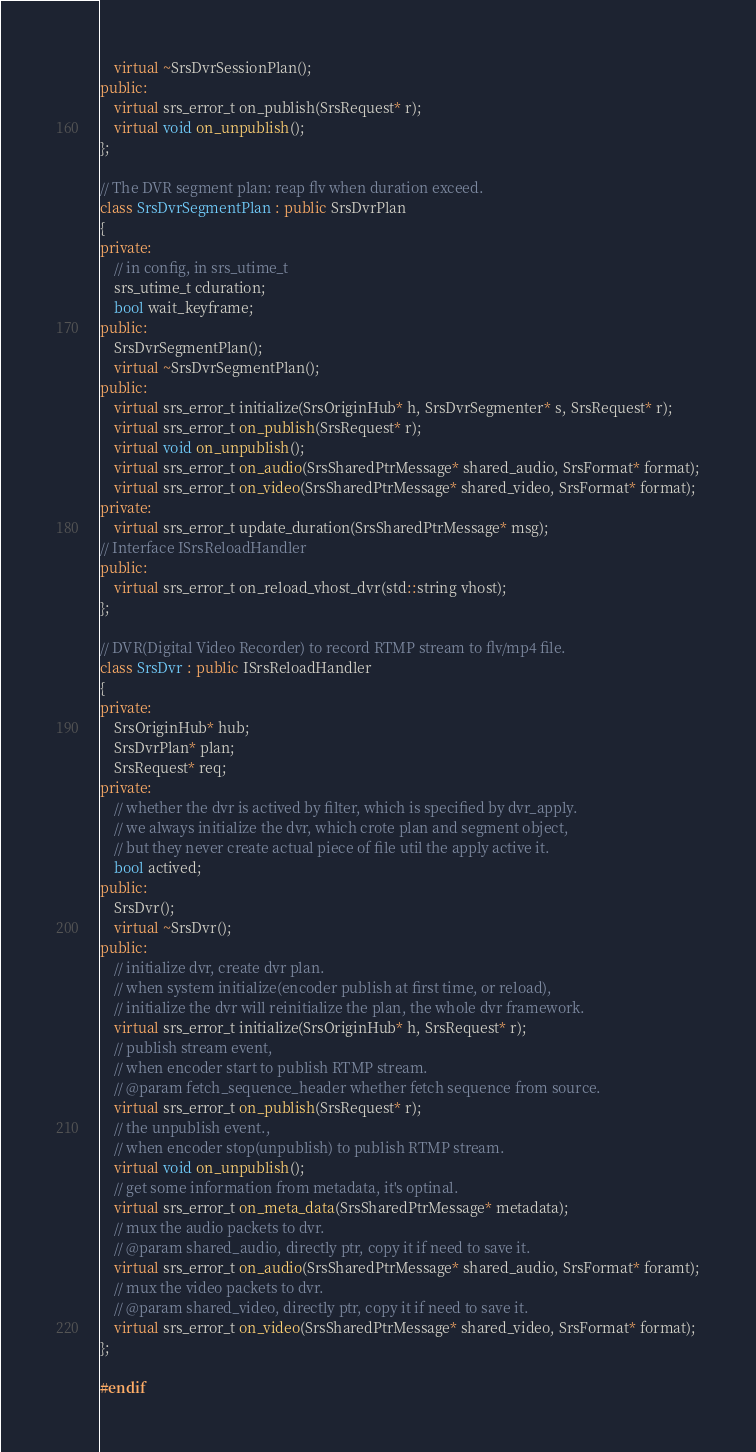Convert code to text. <code><loc_0><loc_0><loc_500><loc_500><_C++_>    virtual ~SrsDvrSessionPlan();
public:
    virtual srs_error_t on_publish(SrsRequest* r);
    virtual void on_unpublish();
};

// The DVR segment plan: reap flv when duration exceed.
class SrsDvrSegmentPlan : public SrsDvrPlan
{
private:
    // in config, in srs_utime_t
    srs_utime_t cduration;
    bool wait_keyframe;
public:
    SrsDvrSegmentPlan();
    virtual ~SrsDvrSegmentPlan();
public:
    virtual srs_error_t initialize(SrsOriginHub* h, SrsDvrSegmenter* s, SrsRequest* r);
    virtual srs_error_t on_publish(SrsRequest* r);
    virtual void on_unpublish();
    virtual srs_error_t on_audio(SrsSharedPtrMessage* shared_audio, SrsFormat* format);
    virtual srs_error_t on_video(SrsSharedPtrMessage* shared_video, SrsFormat* format);
private:
    virtual srs_error_t update_duration(SrsSharedPtrMessage* msg);
// Interface ISrsReloadHandler
public:
    virtual srs_error_t on_reload_vhost_dvr(std::string vhost);
};

// DVR(Digital Video Recorder) to record RTMP stream to flv/mp4 file.
class SrsDvr : public ISrsReloadHandler
{
private:
    SrsOriginHub* hub;
    SrsDvrPlan* plan;
    SrsRequest* req;
private:
    // whether the dvr is actived by filter, which is specified by dvr_apply.
    // we always initialize the dvr, which crote plan and segment object,
    // but they never create actual piece of file util the apply active it.
    bool actived;
public:
    SrsDvr();
    virtual ~SrsDvr();
public:
    // initialize dvr, create dvr plan.
    // when system initialize(encoder publish at first time, or reload),
    // initialize the dvr will reinitialize the plan, the whole dvr framework.
    virtual srs_error_t initialize(SrsOriginHub* h, SrsRequest* r);
    // publish stream event,
    // when encoder start to publish RTMP stream.
    // @param fetch_sequence_header whether fetch sequence from source.
    virtual srs_error_t on_publish(SrsRequest* r);
    // the unpublish event.,
    // when encoder stop(unpublish) to publish RTMP stream.
    virtual void on_unpublish();
    // get some information from metadata, it's optinal.
    virtual srs_error_t on_meta_data(SrsSharedPtrMessage* metadata);
    // mux the audio packets to dvr.
    // @param shared_audio, directly ptr, copy it if need to save it.
    virtual srs_error_t on_audio(SrsSharedPtrMessage* shared_audio, SrsFormat* foramt);
    // mux the video packets to dvr.
    // @param shared_video, directly ptr, copy it if need to save it.
    virtual srs_error_t on_video(SrsSharedPtrMessage* shared_video, SrsFormat* format);
};

#endif

</code> 